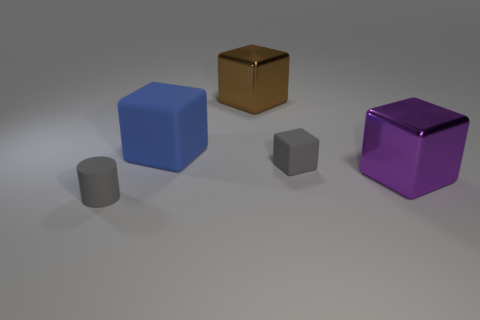Is there a thing that has the same color as the small cube?
Provide a short and direct response. Yes. The rubber thing that is the same color as the small cylinder is what shape?
Make the answer very short. Cube. Are there any other things that have the same color as the large matte cube?
Give a very brief answer. No. Does the small object to the right of the rubber cylinder have the same material as the gray object in front of the purple thing?
Provide a short and direct response. Yes. What is the object that is both to the left of the brown thing and behind the small cylinder made of?
Your answer should be compact. Rubber. There is a blue matte thing; does it have the same shape as the metallic thing that is on the right side of the small block?
Ensure brevity in your answer.  Yes. What material is the purple thing that is to the right of the matte thing that is in front of the big purple metal thing in front of the big matte thing?
Offer a terse response. Metal. What number of other things are the same size as the brown thing?
Your answer should be compact. 2. Is the rubber cylinder the same color as the big rubber thing?
Your answer should be very brief. No. How many cubes are on the right side of the tiny gray matte thing to the right of the metal cube that is to the left of the large purple cube?
Provide a succinct answer. 1. 